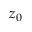Convert formula to latex. <formula><loc_0><loc_0><loc_500><loc_500>z _ { 0 }</formula> 